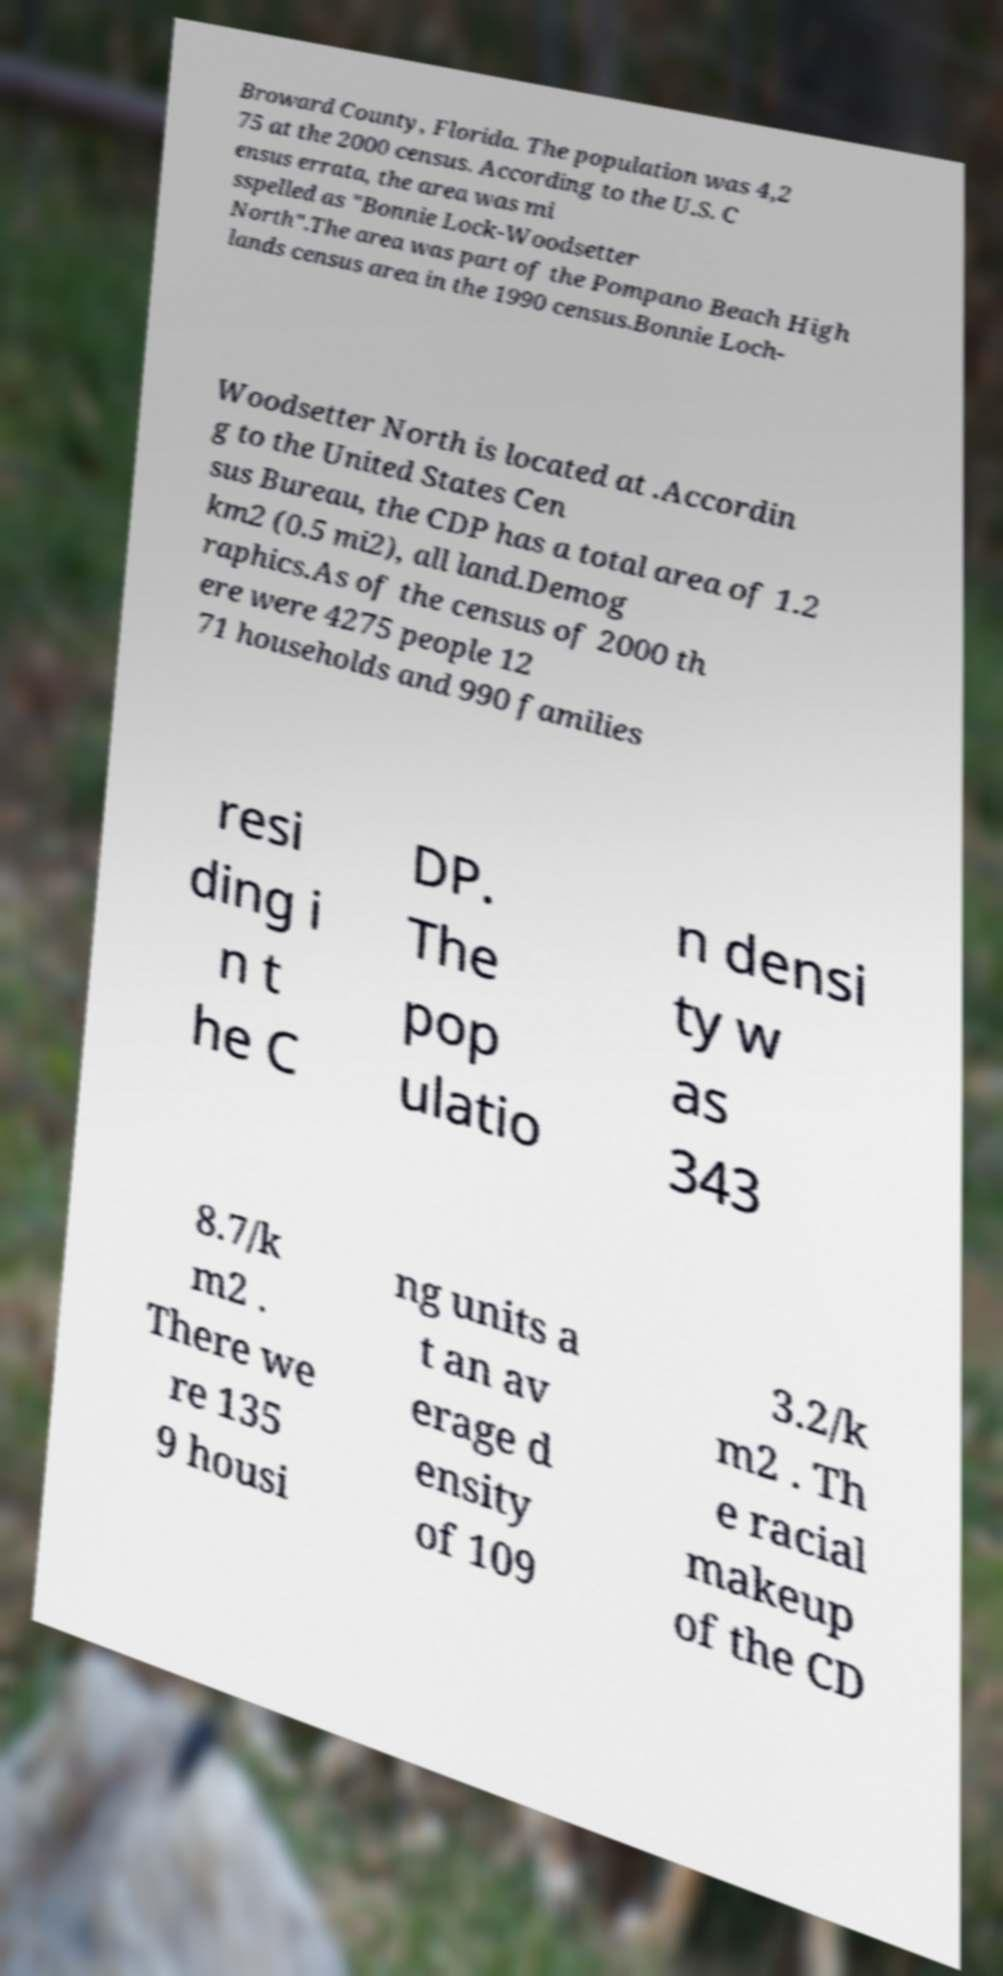I need the written content from this picture converted into text. Can you do that? Broward County, Florida. The population was 4,2 75 at the 2000 census. According to the U.S. C ensus errata, the area was mi sspelled as "Bonnie Lock-Woodsetter North".The area was part of the Pompano Beach High lands census area in the 1990 census.Bonnie Loch- Woodsetter North is located at .Accordin g to the United States Cen sus Bureau, the CDP has a total area of 1.2 km2 (0.5 mi2), all land.Demog raphics.As of the census of 2000 th ere were 4275 people 12 71 households and 990 families resi ding i n t he C DP. The pop ulatio n densi ty w as 343 8.7/k m2 . There we re 135 9 housi ng units a t an av erage d ensity of 109 3.2/k m2 . Th e racial makeup of the CD 